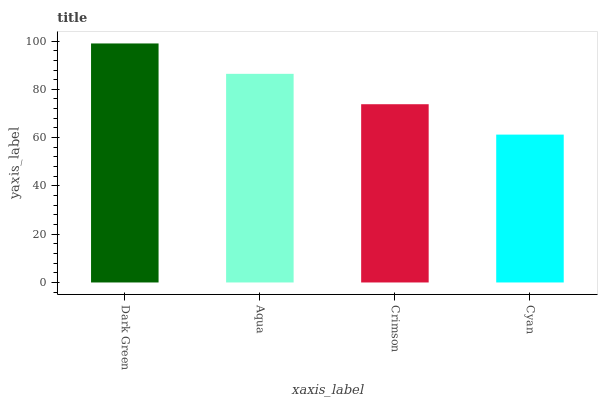Is Cyan the minimum?
Answer yes or no. Yes. Is Dark Green the maximum?
Answer yes or no. Yes. Is Aqua the minimum?
Answer yes or no. No. Is Aqua the maximum?
Answer yes or no. No. Is Dark Green greater than Aqua?
Answer yes or no. Yes. Is Aqua less than Dark Green?
Answer yes or no. Yes. Is Aqua greater than Dark Green?
Answer yes or no. No. Is Dark Green less than Aqua?
Answer yes or no. No. Is Aqua the high median?
Answer yes or no. Yes. Is Crimson the low median?
Answer yes or no. Yes. Is Cyan the high median?
Answer yes or no. No. Is Aqua the low median?
Answer yes or no. No. 